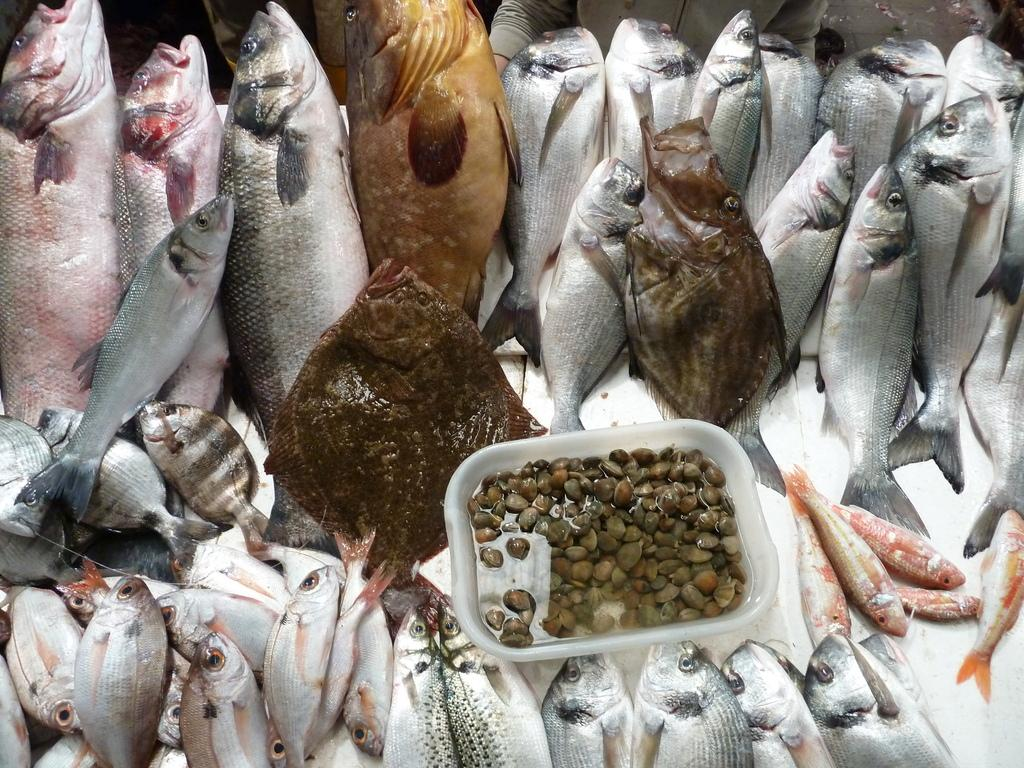What type of animals can be seen on the white surface in the image? There are fishes on a white surface in the image. What is the color of the bowl in the image? The bowl in the image is white. What is inside the white bowl? There are objects in the white bowl. What is the liquid in the white bowl? There is water in the white bowl. What type of copper pickle is being served by the minister in the image? There is no copper pickle or minister present in the image. 